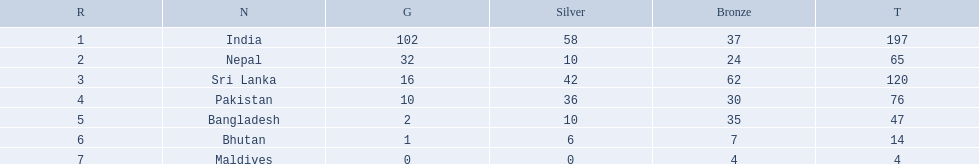Which nations played at the 1999 south asian games? India, Nepal, Sri Lanka, Pakistan, Bangladesh, Bhutan, Maldives. Which country is listed second in the table? Nepal. 